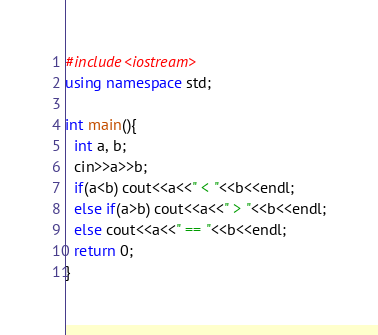<code> <loc_0><loc_0><loc_500><loc_500><_C++_>#include<iostream>
using namespace std;

int main(){
  int a, b;
  cin>>a>>b;
  if(a<b) cout<<a<<" < "<<b<<endl;
  else if(a>b) cout<<a<<" > "<<b<<endl;
  else cout<<a<<" == "<<b<<endl;
  return 0;
}</code> 